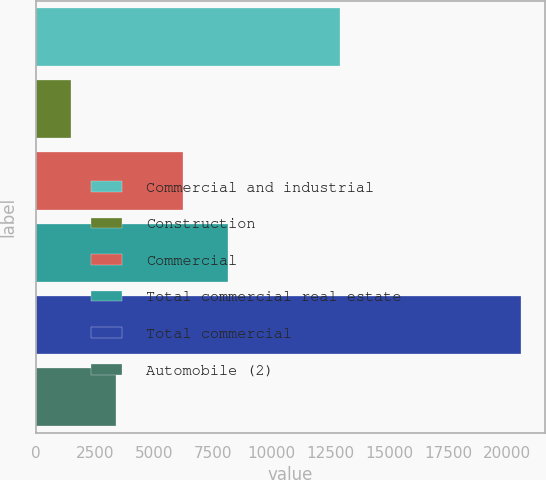Convert chart to OTSL. <chart><loc_0><loc_0><loc_500><loc_500><bar_chart><fcel>Commercial and industrial<fcel>Construction<fcel>Commercial<fcel>Total commercial real estate<fcel>Total commercial<fcel>Automobile (2)<nl><fcel>12888<fcel>1469<fcel>6220<fcel>8130.8<fcel>20577<fcel>3390<nl></chart> 